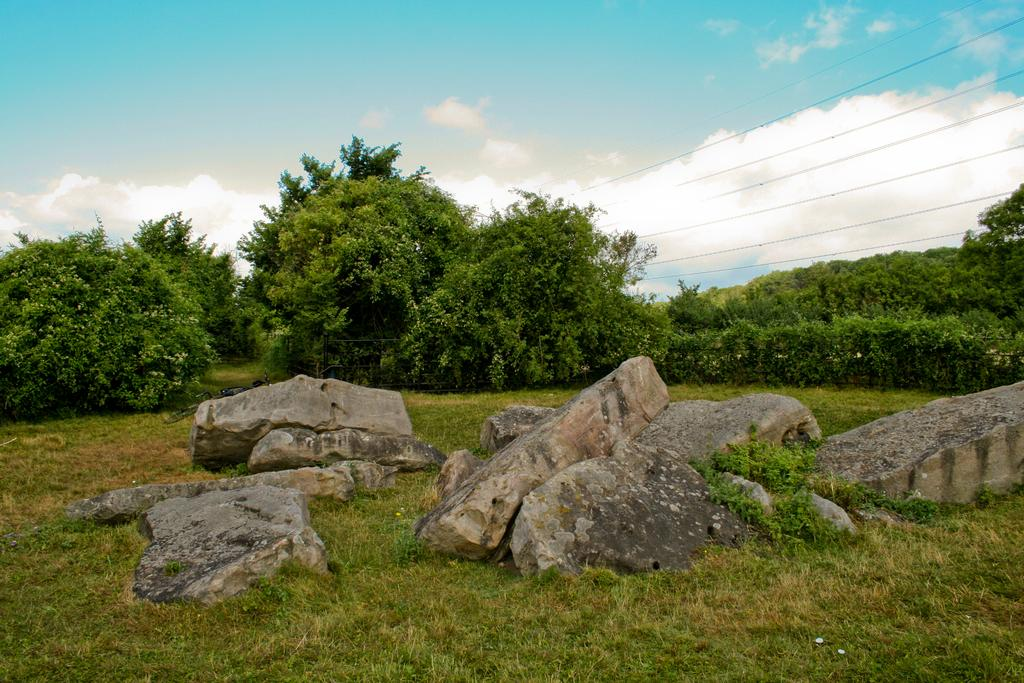What type of vegetation can be seen in the image? There is grass in the image. What objects are located in front in the image? There are rocks in front in the image. What can be found in the middle of the image? There are trees and wires in the middle of the image. What is visible in the background of the image? The sky is visible in the background of the image. What type of lace can be seen on the trees in the image? There is no lace present on the trees in the image; they are natural trees without any decorations. 